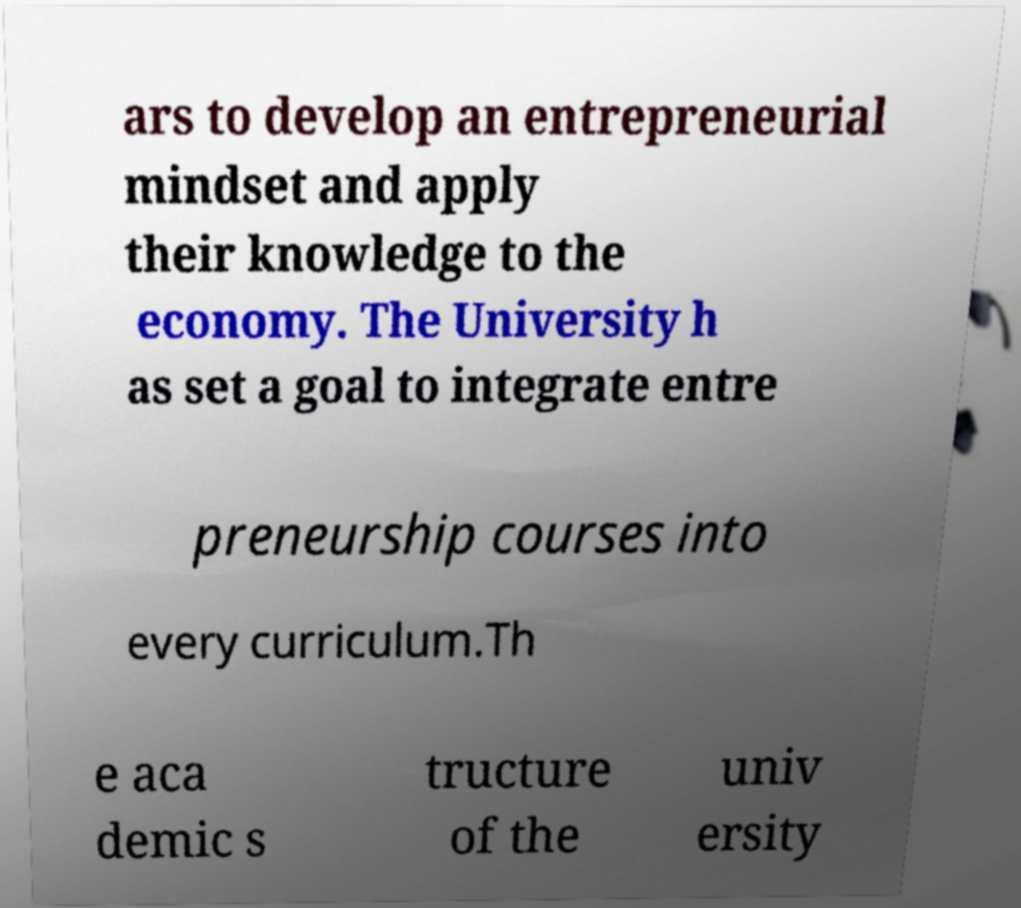There's text embedded in this image that I need extracted. Can you transcribe it verbatim? ars to develop an entrepreneurial mindset and apply their knowledge to the economy. The University h as set a goal to integrate entre preneurship courses into every curriculum.Th e aca demic s tructure of the univ ersity 